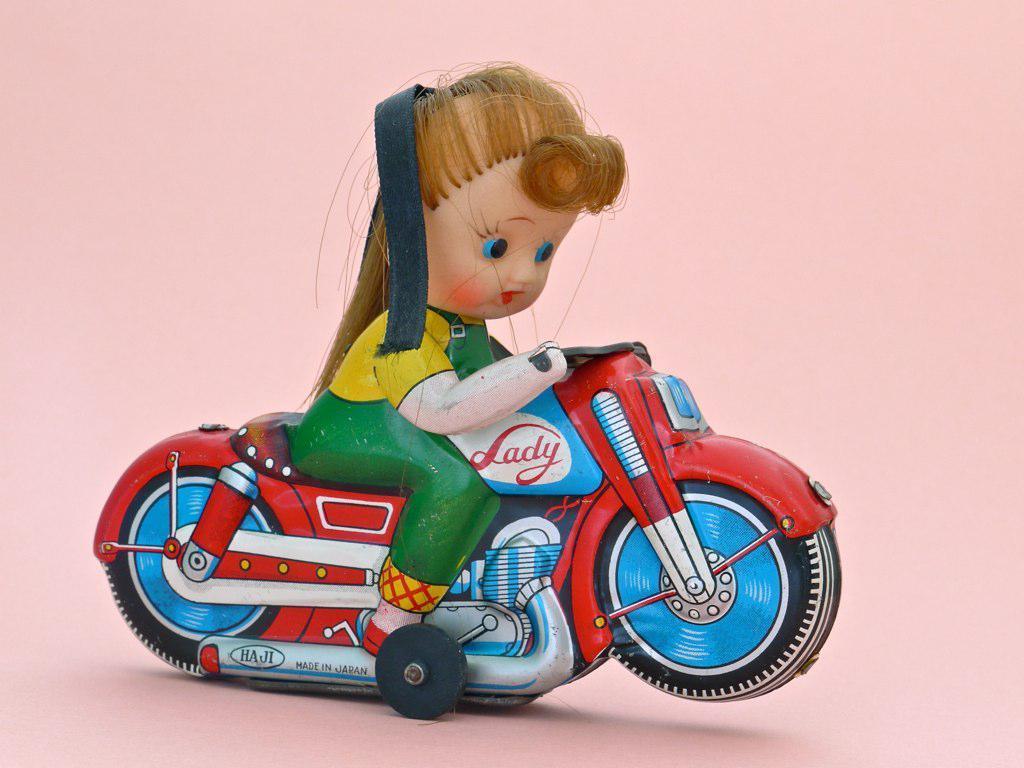Describe this image in one or two sentences. In the center of this picture we can see a toy of a girl seems to be riding a toy bike. The background of the image is pink in color. 